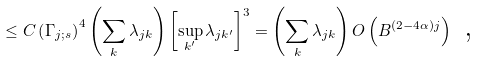Convert formula to latex. <formula><loc_0><loc_0><loc_500><loc_500>\leq C \left ( \Gamma _ { j ; s } \right ) ^ { 4 } \left ( \sum _ { k } \lambda _ { j k } \right ) \left [ \sup _ { k ^ { \prime } } \lambda _ { j k ^ { \prime } } \right ] ^ { 3 } = \left ( \sum _ { k } \lambda _ { j k } \right ) O \left ( B ^ { \left ( 2 - 4 \alpha \right ) j } \right ) \text { ,}</formula> 